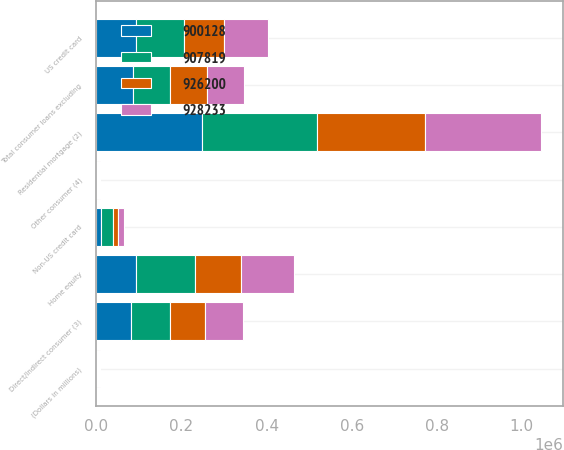Convert chart. <chart><loc_0><loc_0><loc_500><loc_500><stacked_bar_chart><ecel><fcel>(Dollars in millions)<fcel>Residential mortgage (2)<fcel>Home equity<fcel>US credit card<fcel>Non-US credit card<fcel>Direct/Indirect consumer (3)<fcel>Other consumer (4)<fcel>Total consumer loans excluding<nl><fcel>900128<fcel>2013<fcel>248066<fcel>93672<fcel>92338<fcel>11541<fcel>82192<fcel>1977<fcel>86459<nl><fcel>926200<fcel>2012<fcel>252929<fcel>108140<fcel>94835<fcel>11697<fcel>83205<fcel>1628<fcel>86459<nl><fcel>928233<fcel>2011<fcel>273228<fcel>124856<fcel>102291<fcel>14418<fcel>89713<fcel>2688<fcel>86459<nl><fcel>907819<fcel>2010<fcel>270901<fcel>138161<fcel>113785<fcel>27465<fcel>90308<fcel>2830<fcel>86459<nl></chart> 